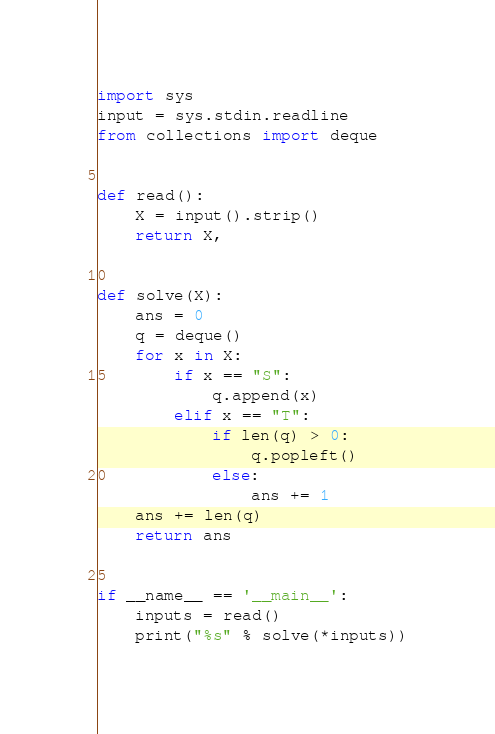<code> <loc_0><loc_0><loc_500><loc_500><_Python_>import sys
input = sys.stdin.readline
from collections import deque


def read():
    X = input().strip()
    return X,


def solve(X):
    ans = 0
    q = deque()
    for x in X:
        if x == "S":
            q.append(x)
        elif x == "T":
            if len(q) > 0:
                q.popleft()
            else:
                ans += 1
    ans += len(q)
    return ans


if __name__ == '__main__':
    inputs = read()
    print("%s" % solve(*inputs))
</code> 